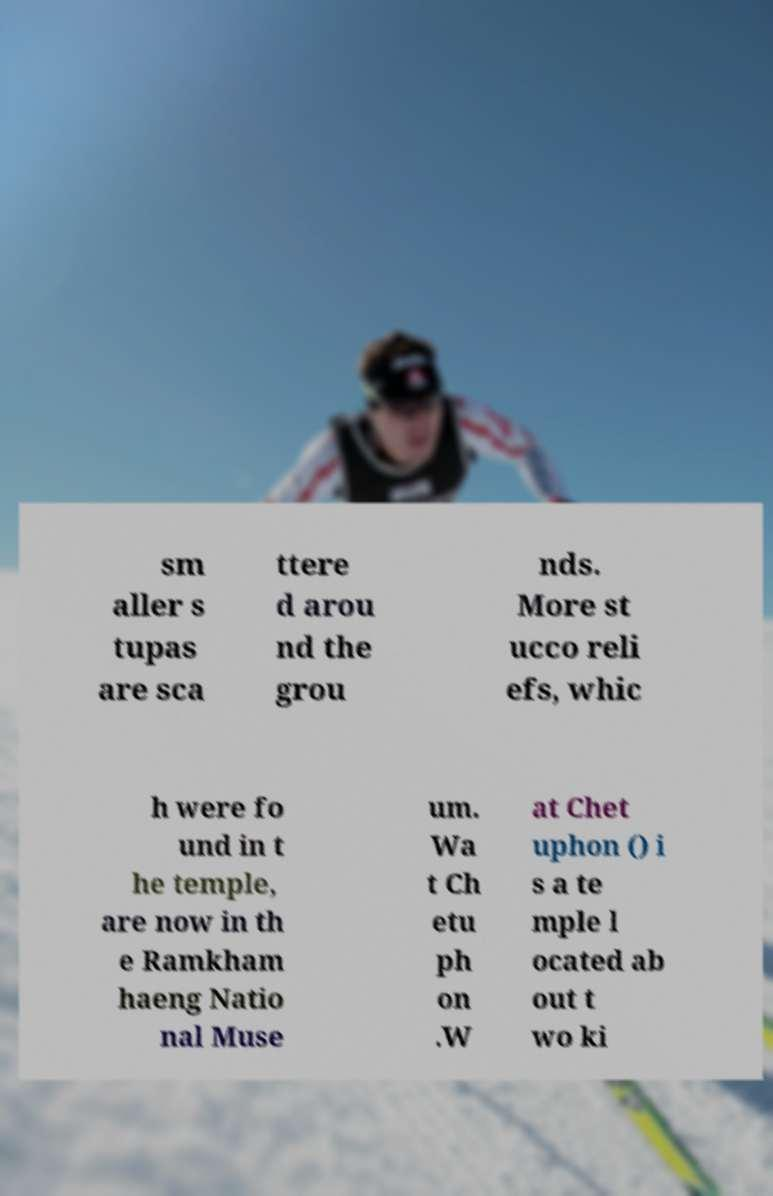Please identify and transcribe the text found in this image. sm aller s tupas are sca ttere d arou nd the grou nds. More st ucco reli efs, whic h were fo und in t he temple, are now in th e Ramkham haeng Natio nal Muse um. Wa t Ch etu ph on .W at Chet uphon () i s a te mple l ocated ab out t wo ki 